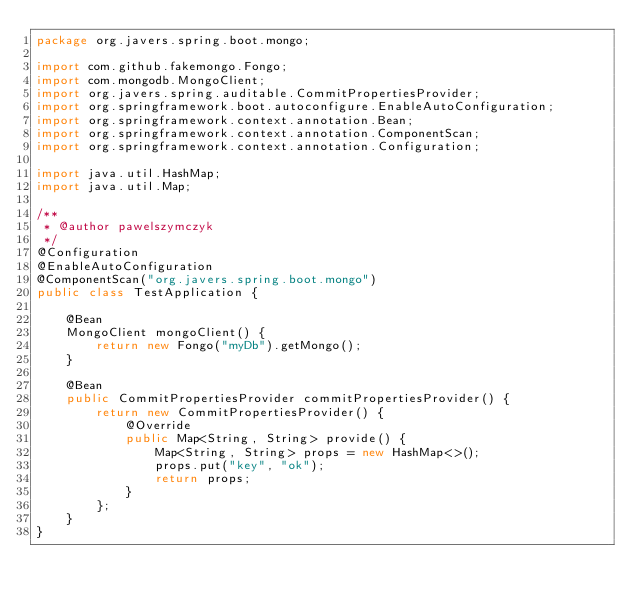Convert code to text. <code><loc_0><loc_0><loc_500><loc_500><_Java_>package org.javers.spring.boot.mongo;

import com.github.fakemongo.Fongo;
import com.mongodb.MongoClient;
import org.javers.spring.auditable.CommitPropertiesProvider;
import org.springframework.boot.autoconfigure.EnableAutoConfiguration;
import org.springframework.context.annotation.Bean;
import org.springframework.context.annotation.ComponentScan;
import org.springframework.context.annotation.Configuration;

import java.util.HashMap;
import java.util.Map;

/**
 * @author pawelszymczyk
 */
@Configuration
@EnableAutoConfiguration
@ComponentScan("org.javers.spring.boot.mongo")
public class TestApplication {

    @Bean
    MongoClient mongoClient() {
        return new Fongo("myDb").getMongo();
    }

    @Bean
    public CommitPropertiesProvider commitPropertiesProvider() {
        return new CommitPropertiesProvider() {
            @Override
            public Map<String, String> provide() {
                Map<String, String> props = new HashMap<>();
                props.put("key", "ok");
                return props;
            }
        };
    }
}
</code> 